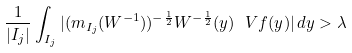Convert formula to latex. <formula><loc_0><loc_0><loc_500><loc_500>\frac { 1 } { | I _ { j } | } \int _ { I _ { j } } | ( m _ { I _ { j } } ( W ^ { - 1 } ) ) ^ { - \frac { 1 } { 2 } } W ^ { - \frac { 1 } { 2 } } ( y ) \ V { f } ( y ) | \, d y > \lambda</formula> 